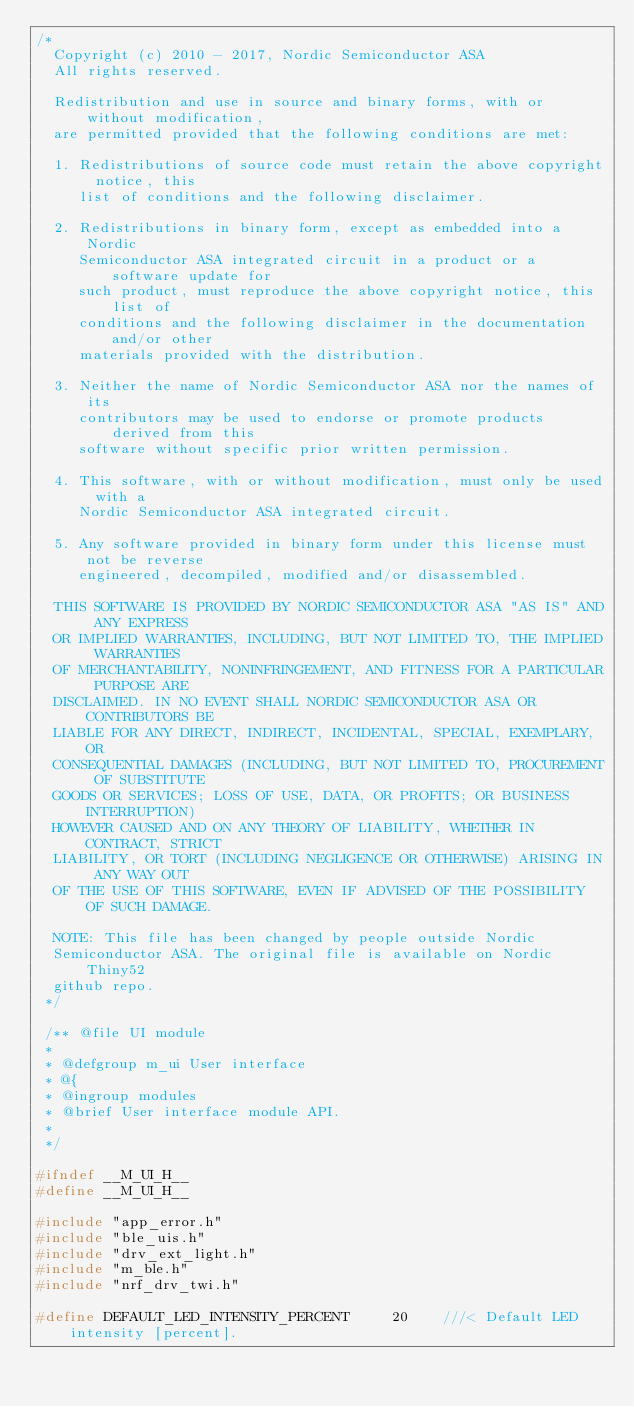<code> <loc_0><loc_0><loc_500><loc_500><_C_>/*
  Copyright (c) 2010 - 2017, Nordic Semiconductor ASA
  All rights reserved.

  Redistribution and use in source and binary forms, with or without modification,
  are permitted provided that the following conditions are met:

  1. Redistributions of source code must retain the above copyright notice, this
     list of conditions and the following disclaimer.

  2. Redistributions in binary form, except as embedded into a Nordic
     Semiconductor ASA integrated circuit in a product or a software update for
     such product, must reproduce the above copyright notice, this list of
     conditions and the following disclaimer in the documentation and/or other
     materials provided with the distribution.

  3. Neither the name of Nordic Semiconductor ASA nor the names of its
     contributors may be used to endorse or promote products derived from this
     software without specific prior written permission.

  4. This software, with or without modification, must only be used with a
     Nordic Semiconductor ASA integrated circuit.

  5. Any software provided in binary form under this license must not be reverse
     engineered, decompiled, modified and/or disassembled.

  THIS SOFTWARE IS PROVIDED BY NORDIC SEMICONDUCTOR ASA "AS IS" AND ANY EXPRESS
  OR IMPLIED WARRANTIES, INCLUDING, BUT NOT LIMITED TO, THE IMPLIED WARRANTIES
  OF MERCHANTABILITY, NONINFRINGEMENT, AND FITNESS FOR A PARTICULAR PURPOSE ARE
  DISCLAIMED. IN NO EVENT SHALL NORDIC SEMICONDUCTOR ASA OR CONTRIBUTORS BE
  LIABLE FOR ANY DIRECT, INDIRECT, INCIDENTAL, SPECIAL, EXEMPLARY, OR
  CONSEQUENTIAL DAMAGES (INCLUDING, BUT NOT LIMITED TO, PROCUREMENT OF SUBSTITUTE
  GOODS OR SERVICES; LOSS OF USE, DATA, OR PROFITS; OR BUSINESS INTERRUPTION)
  HOWEVER CAUSED AND ON ANY THEORY OF LIABILITY, WHETHER IN CONTRACT, STRICT
  LIABILITY, OR TORT (INCLUDING NEGLIGENCE OR OTHERWISE) ARISING IN ANY WAY OUT
  OF THE USE OF THIS SOFTWARE, EVEN IF ADVISED OF THE POSSIBILITY OF SUCH DAMAGE.

  NOTE: This file has been changed by people outside Nordic
  Semiconductor ASA. The original file is available on Nordic Thiny52
  github repo.
 */

 /** @file UI module
 *
 * @defgroup m_ui User interface
 * @{
 * @ingroup modules
 * @brief User interface module API.
 *
 */

#ifndef __M_UI_H__
#define __M_UI_H__

#include "app_error.h"
#include "ble_uis.h"
#include "drv_ext_light.h"
#include "m_ble.h"
#include "nrf_drv_twi.h"

#define DEFAULT_LED_INTENSITY_PERCENT     20    ///< Default LED intensity [percent].</code> 